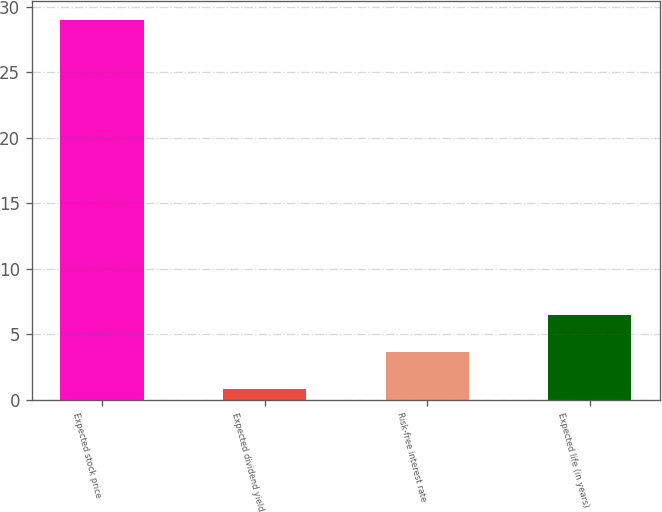Convert chart. <chart><loc_0><loc_0><loc_500><loc_500><bar_chart><fcel>Expected stock price<fcel>Expected dividend yield<fcel>Risk-free interest rate<fcel>Expected life (in years)<nl><fcel>29<fcel>0.8<fcel>3.62<fcel>6.44<nl></chart> 